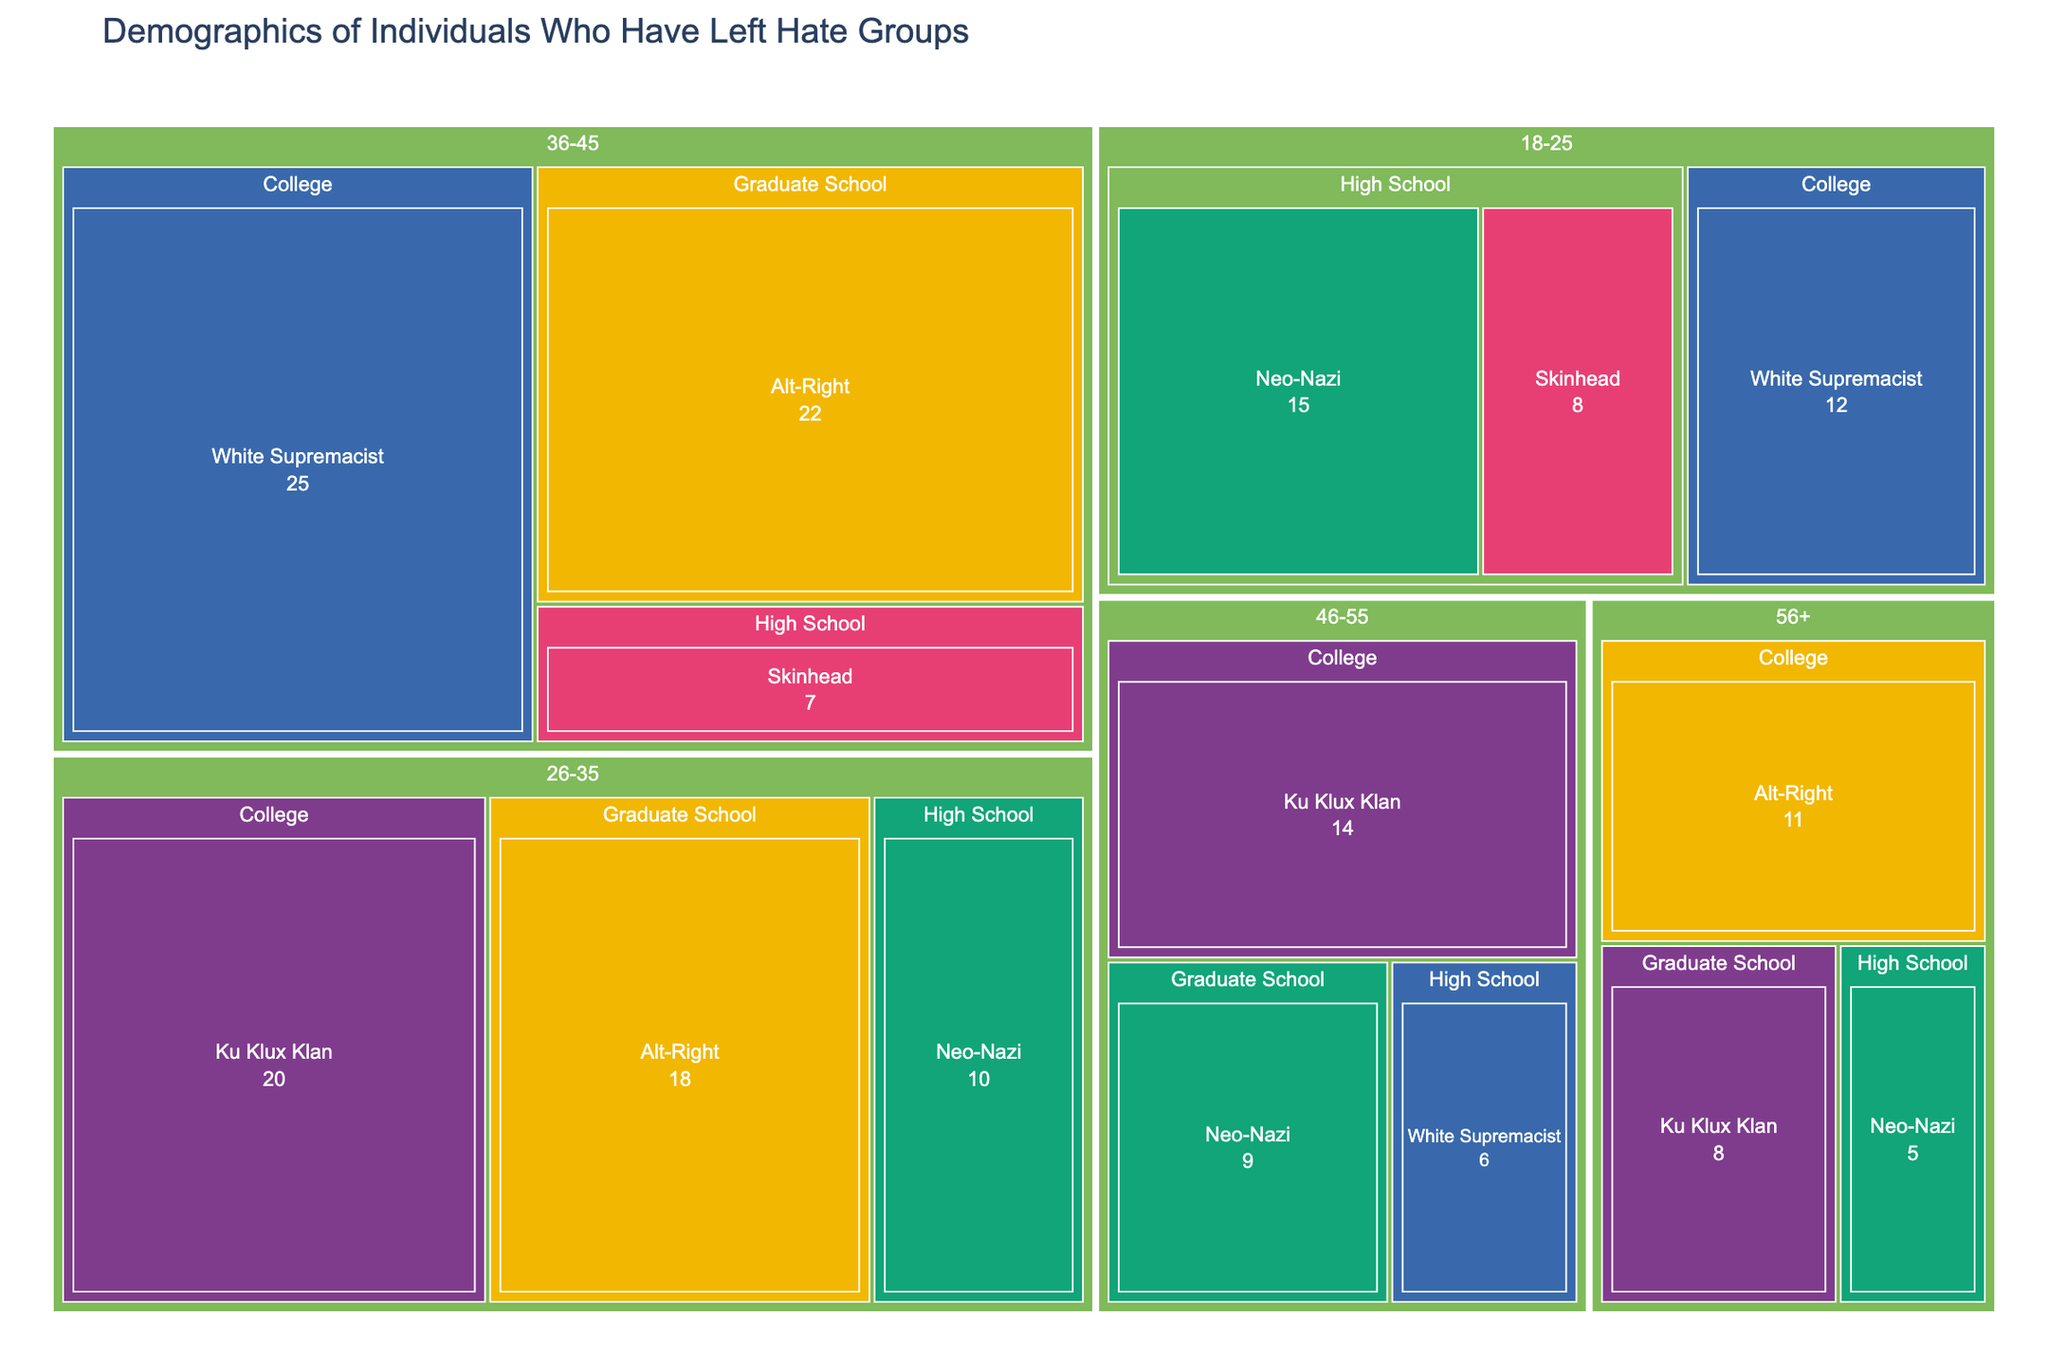What is the title of the treemap figure? The title is typically found at the top of the figure. In this case, it reads "Demographics of Individuals Who Have Left Hate Groups."
Answer: Demographics of Individuals Who Have Left Hate Groups Which age group has the highest count of individuals who left the White Supremacist group? Look for the largest area labeled "White Supremacist" within each age group. The age group 36-45 has the largest count associated with this affiliation.
Answer: 36-45 How many individuals with a Graduate School education have left Alt-Right groups? Navigate to the Graduate School section and then find the corresponding Alt-Right segment. The count is displayed within the segment.
Answer: 22 What is the total count of individuals aged 56+ who have left hate groups? Sum the counts for all segments within the 56+ age group. These are 11 (College, Alt-Right), 8 (Graduate School, Ku Klux Klan), and 5 (High School, Neo-Nazi). The total is 11 + 8 + 5 = 24.
Answer: 24 Which group has the largest representation in the 26-35 age range? Locate the 26-35 age group and evaluate the sizes of the segments. The Ku Klux Klan (20) and Alt-Right (18) are the largest, but Ku Klux Klan has a slightly larger count.
Answer: Ku Klux Klan What is the combined count of individuals with High School education across all age groups? Sum the counts for the High School segment in each age group. These are 15 (18-25, Neo-Nazi), 8 (18-25, Skinhead), 10 (26-35, Neo-Nazi), 7 (36-45, Skinhead), 6 (46-55, White Supremacist), and 5 (56+, Neo-Nazi). The total is 15 + 8 + 10 + 7 + 6 + 5 = 51.
Answer: 51 Which former affiliation has the lowest number of individuals aged 46-55? Within the 46-55 age group, compare the sizes and counts of segments. The segment with the smallest number is High School, White Supremacist with a count of 6.
Answer: White Supremacist (High School) How many age groups have individuals with College education who left the Ku Klux Klan? Determine how many distinct age groups contain a segment for "College, Ku Klux Klan." These groups are 26-35 (20) and 46-55 (14).
Answer: 2 What is the proportion of Neo-Nazi leavers in the 18-25 age range compared to the 26-35 age range? For Neo-Nazi in the 18-25 age group, the count is 15. In the 26-35 age group, the count is 10. The proportion is 15/10 = 1.5.
Answer: 1.5 Which age group has the most diverse educational backgrounds among leavers? Assess which age group has the most distinct education segments. Both the 26-35 and 36-45 age groups have three distinct educational backgrounds each, making them the most diverse.
Answer: 26-35 and 36-45 